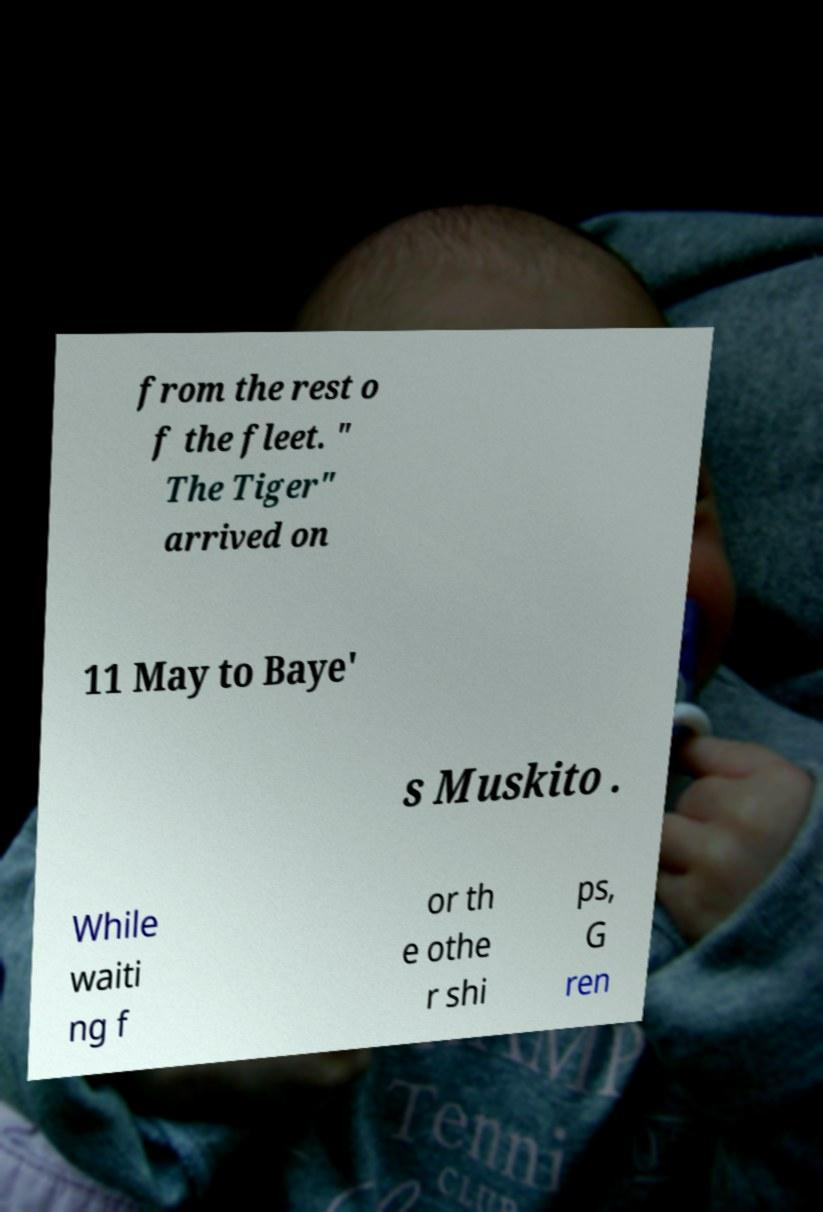Could you extract and type out the text from this image? from the rest o f the fleet. " The Tiger" arrived on 11 May to Baye' s Muskito . While waiti ng f or th e othe r shi ps, G ren 